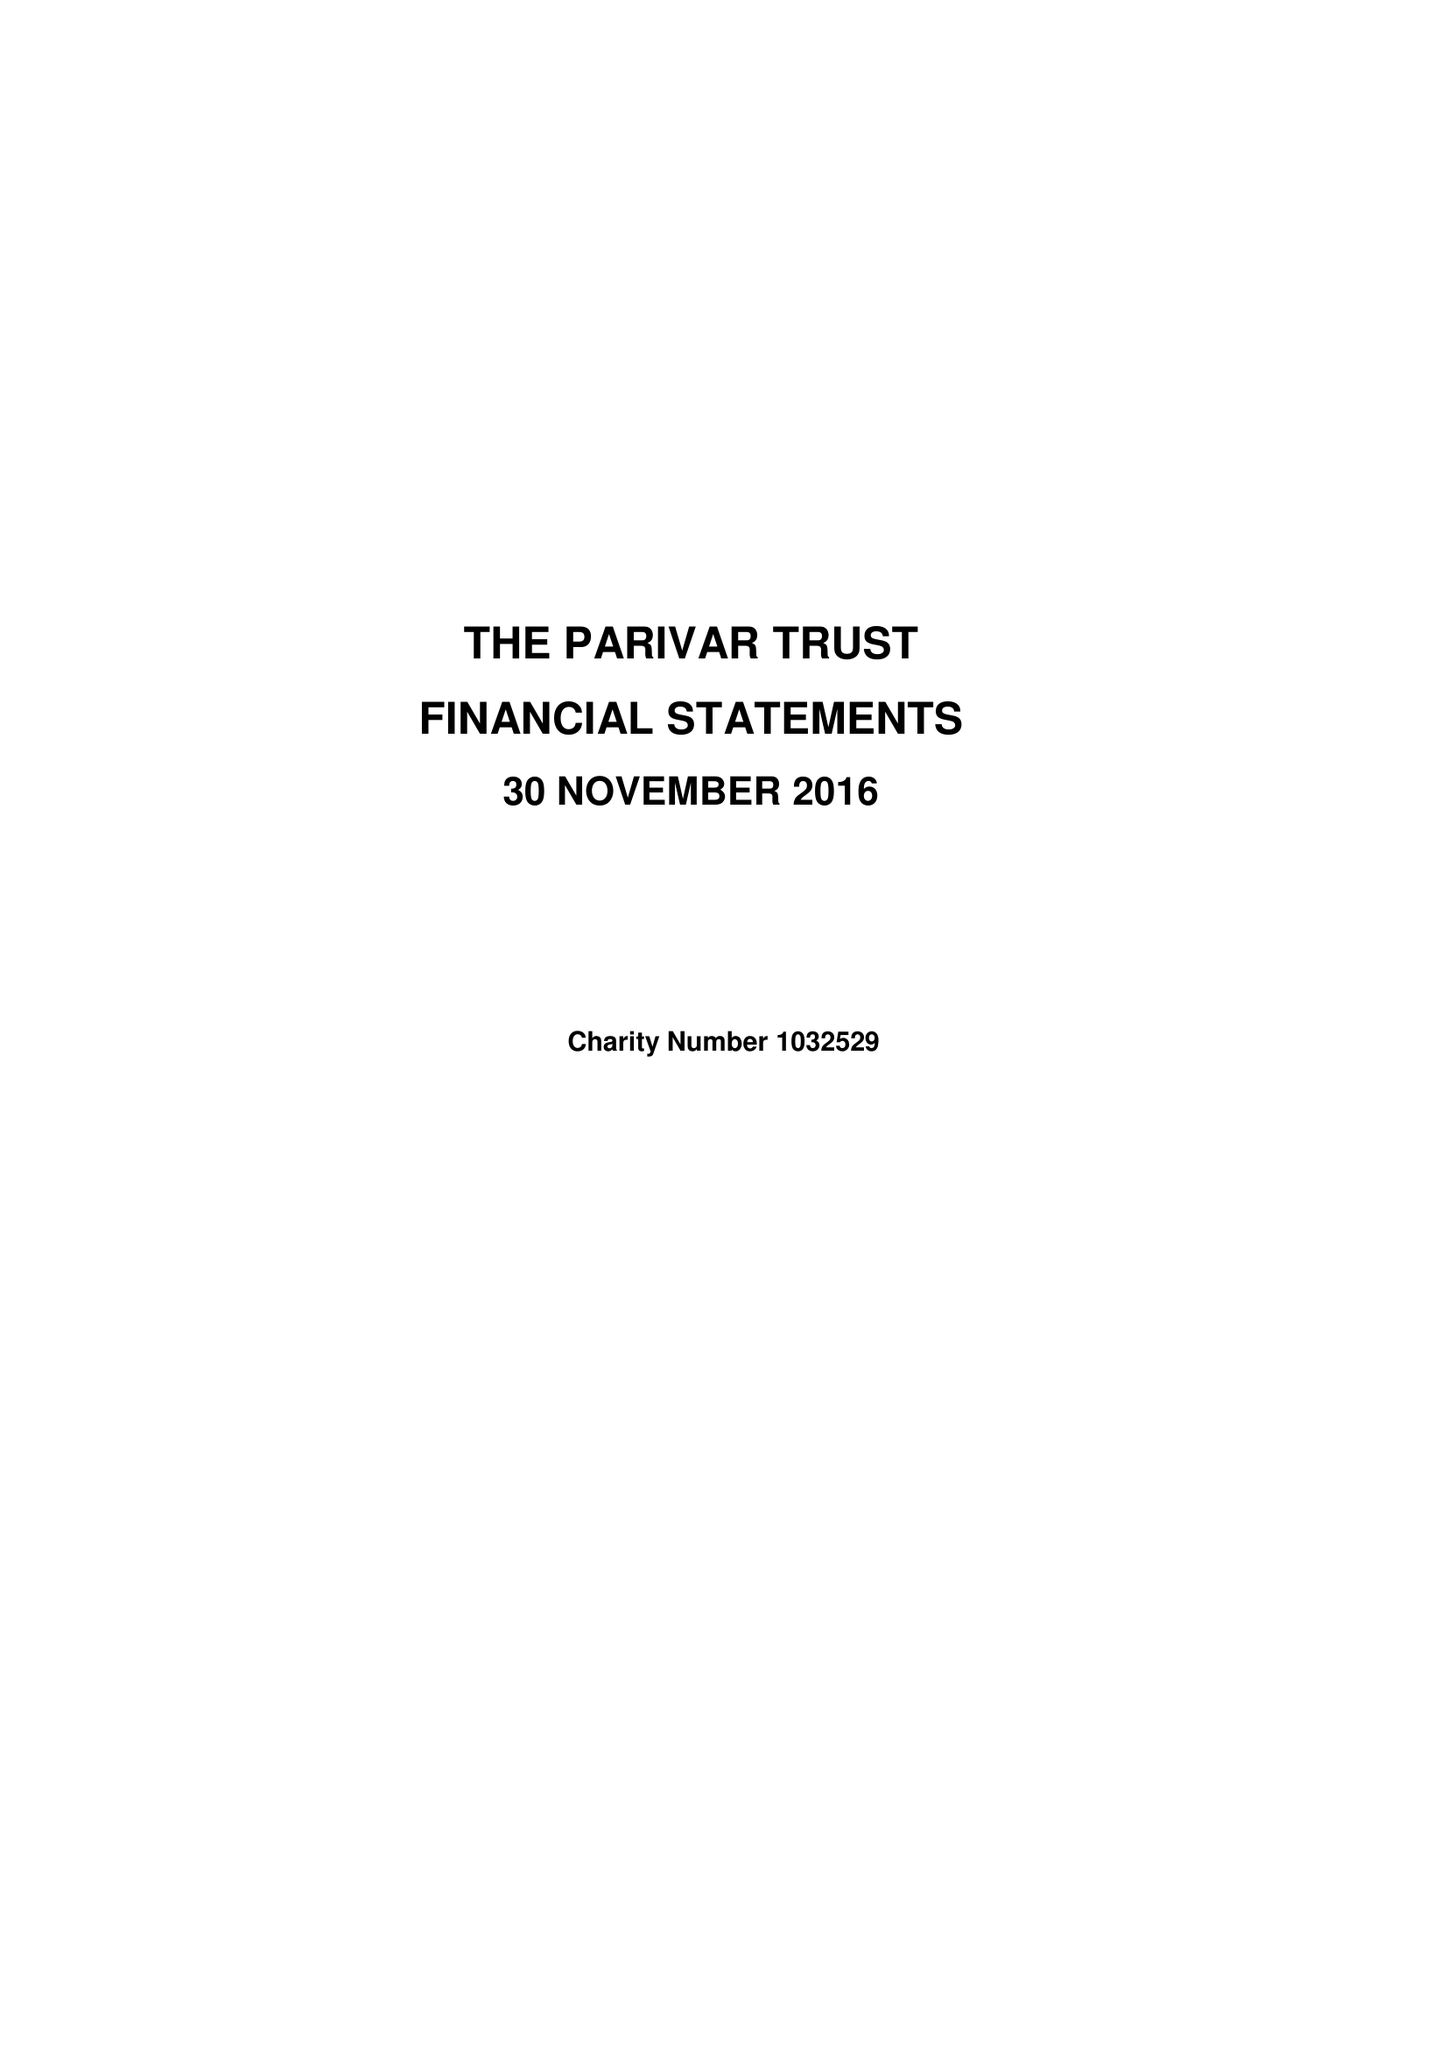What is the value for the address__street_line?
Answer the question using a single word or phrase. None 